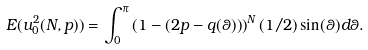Convert formula to latex. <formula><loc_0><loc_0><loc_500><loc_500>E ( u ^ { 2 } _ { 0 } ( N , p ) ) = \int _ { 0 } ^ { \pi } \left ( 1 - ( 2 p - q ( \theta ) ) \right ) ^ { N } ( 1 / 2 ) \sin ( \theta ) d \theta .</formula> 